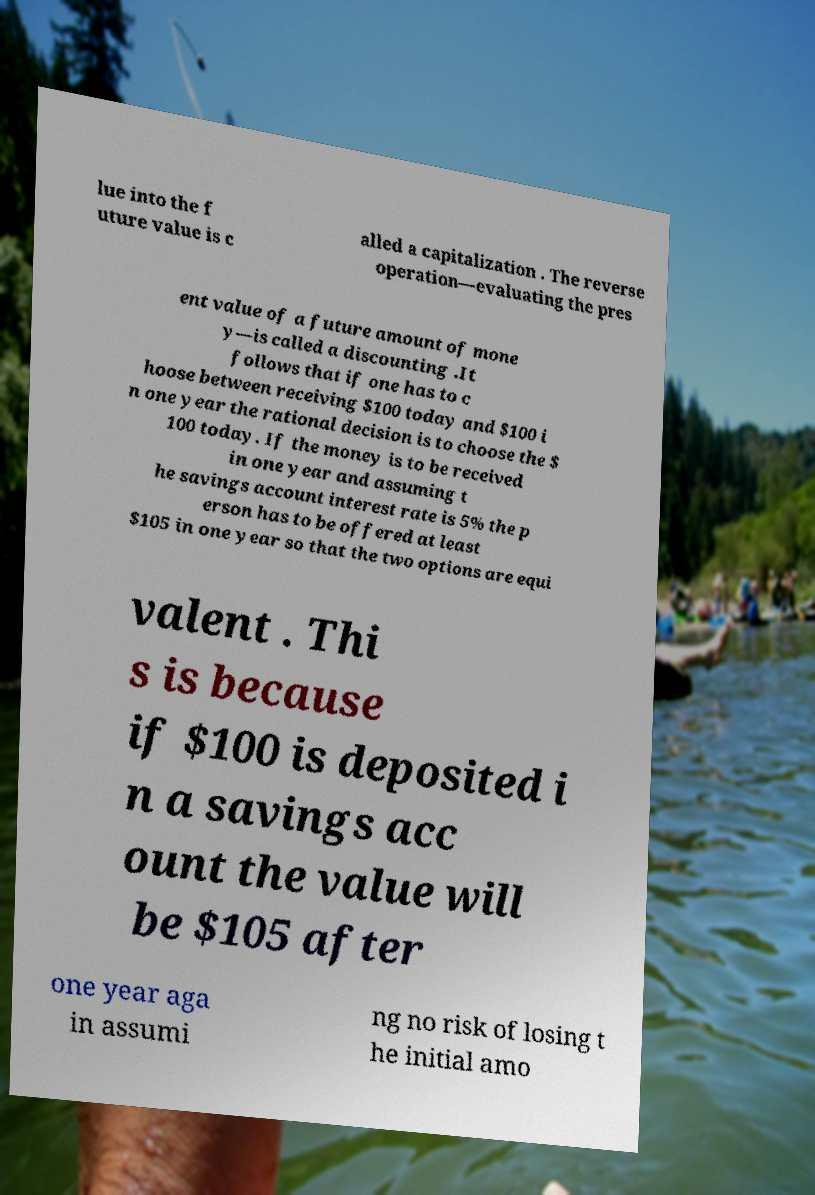Can you accurately transcribe the text from the provided image for me? lue into the f uture value is c alled a capitalization . The reverse operation—evaluating the pres ent value of a future amount of mone y—is called a discounting .It follows that if one has to c hoose between receiving $100 today and $100 i n one year the rational decision is to choose the $ 100 today. If the money is to be received in one year and assuming t he savings account interest rate is 5% the p erson has to be offered at least $105 in one year so that the two options are equi valent . Thi s is because if $100 is deposited i n a savings acc ount the value will be $105 after one year aga in assumi ng no risk of losing t he initial amo 